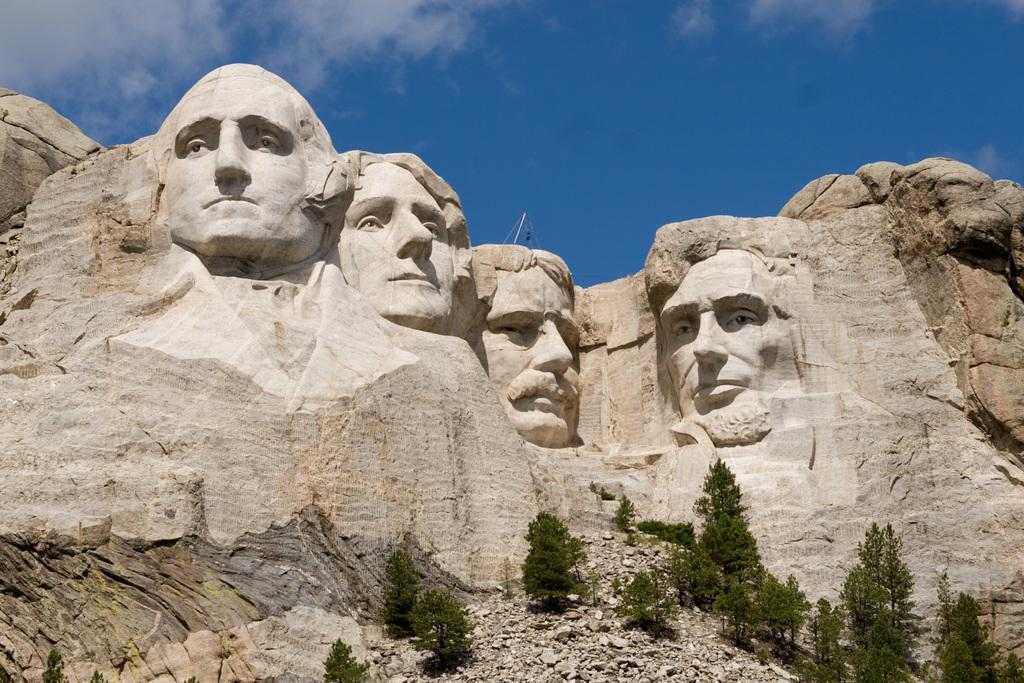What natural formation is depicted in the image? There are rock hills shaped like a man's face in the image. What is located beneath the rock hills? There are plants under the rock hills. What can be seen behind the rock hills? The sky is visible behind the rock hills. What is the condition of the sky in the image? Clouds are present in the sky. What type of shade is being provided by the rock hills in the image? There is no shade being provided by the rock hills in the image, as they are shaped like a man's face and not a structure that would cast a shadow. 